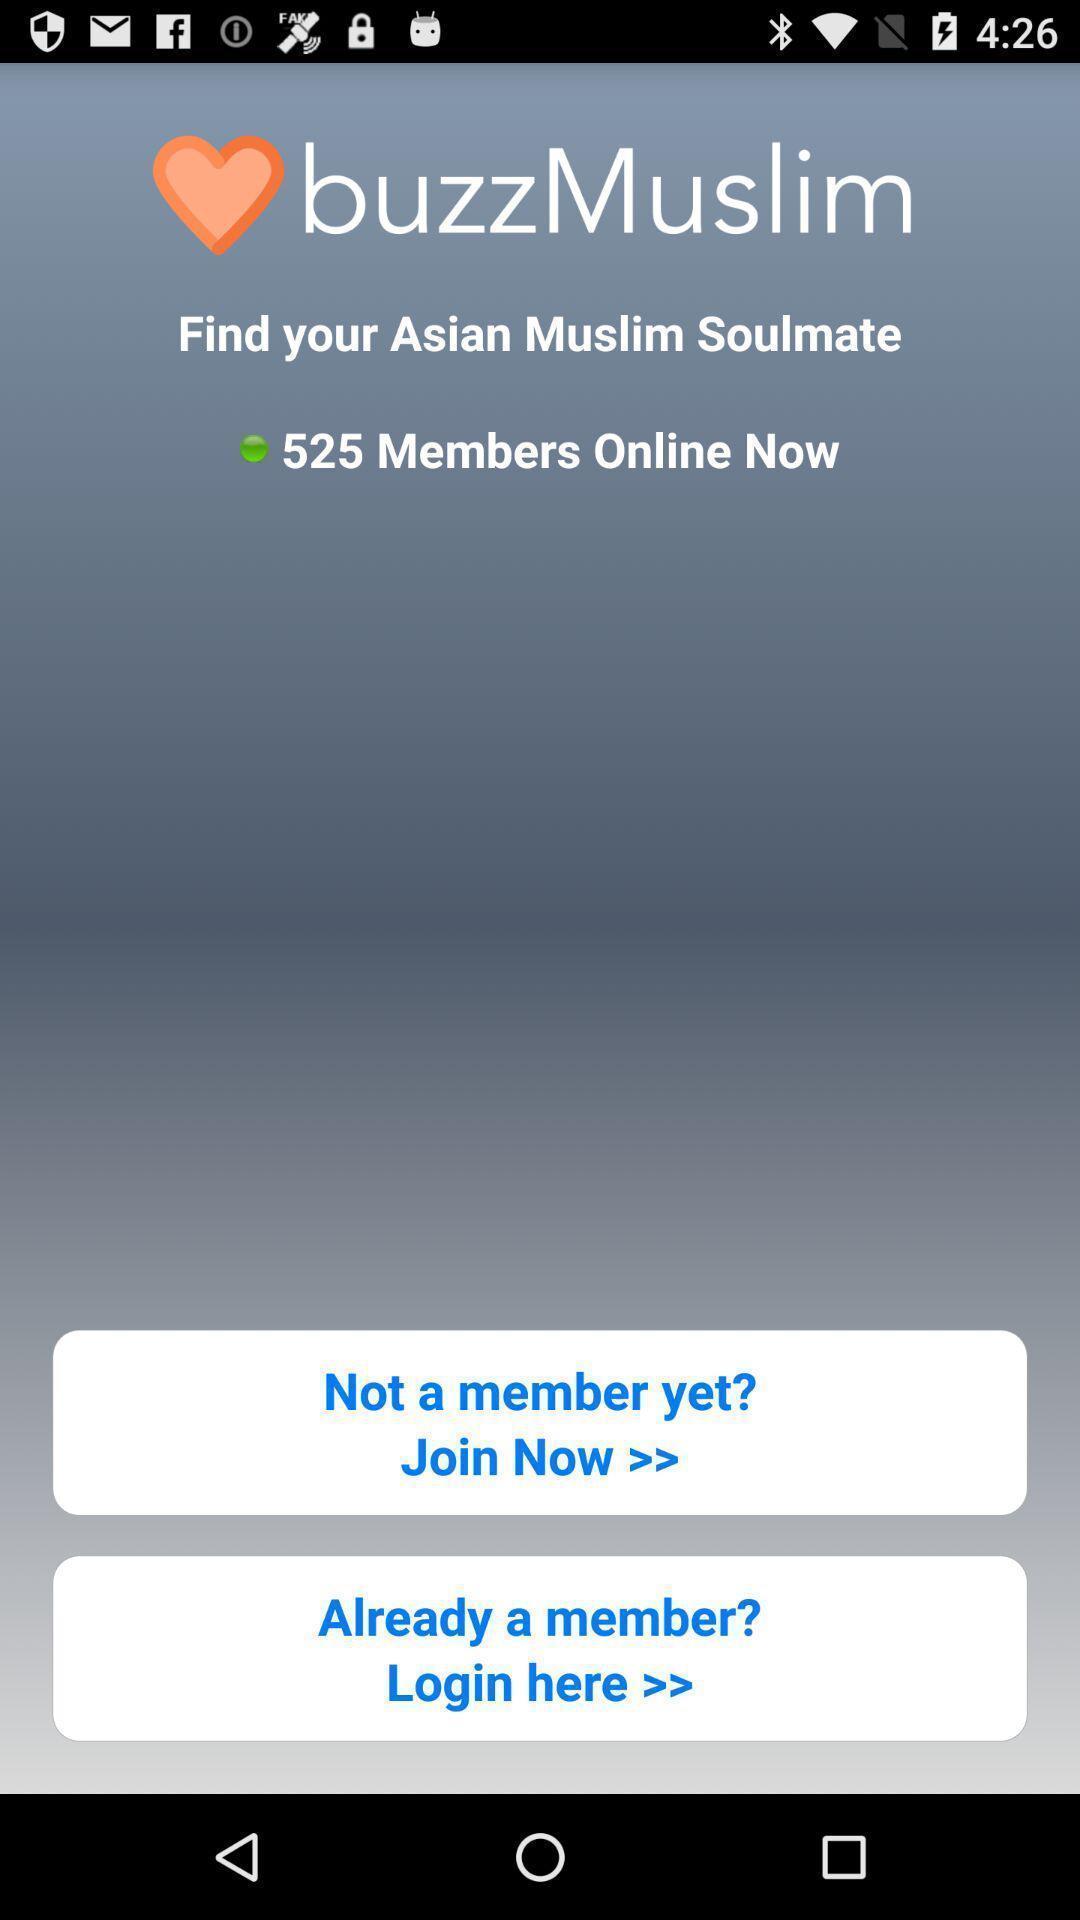What can you discern from this picture? Screen displaying the login page. 